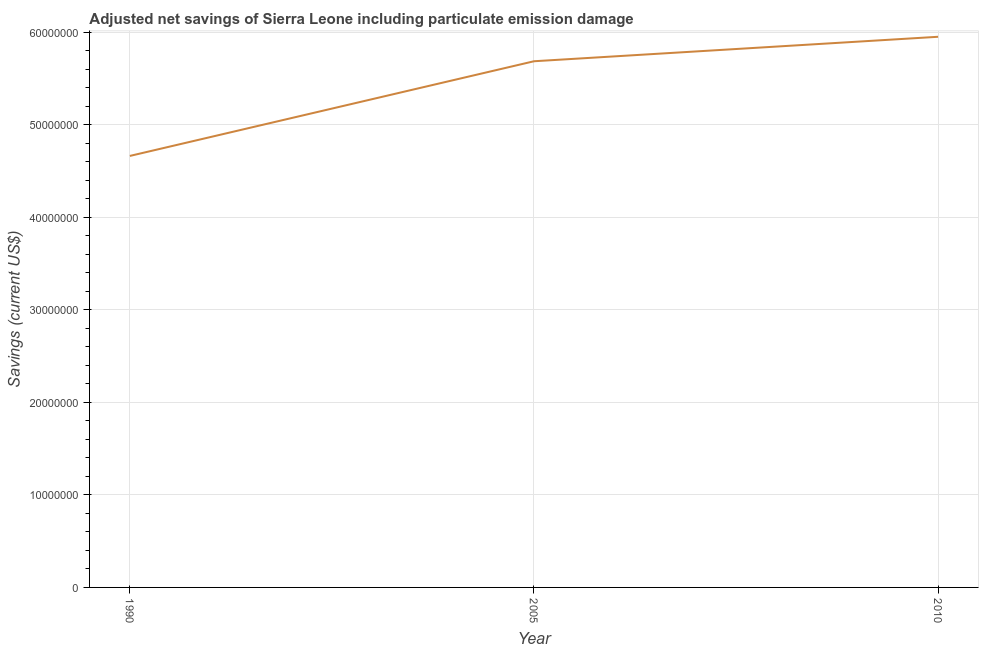What is the adjusted net savings in 1990?
Offer a very short reply. 4.66e+07. Across all years, what is the maximum adjusted net savings?
Make the answer very short. 5.95e+07. Across all years, what is the minimum adjusted net savings?
Your response must be concise. 4.66e+07. In which year was the adjusted net savings minimum?
Give a very brief answer. 1990. What is the sum of the adjusted net savings?
Ensure brevity in your answer.  1.63e+08. What is the difference between the adjusted net savings in 1990 and 2010?
Provide a succinct answer. -1.29e+07. What is the average adjusted net savings per year?
Provide a short and direct response. 5.43e+07. What is the median adjusted net savings?
Provide a short and direct response. 5.69e+07. In how many years, is the adjusted net savings greater than 38000000 US$?
Ensure brevity in your answer.  3. What is the ratio of the adjusted net savings in 2005 to that in 2010?
Your answer should be very brief. 0.96. Is the difference between the adjusted net savings in 2005 and 2010 greater than the difference between any two years?
Your answer should be compact. No. What is the difference between the highest and the second highest adjusted net savings?
Provide a succinct answer. 2.64e+06. What is the difference between the highest and the lowest adjusted net savings?
Give a very brief answer. 1.29e+07. In how many years, is the adjusted net savings greater than the average adjusted net savings taken over all years?
Your response must be concise. 2. Does the adjusted net savings monotonically increase over the years?
Offer a very short reply. Yes. How many years are there in the graph?
Offer a terse response. 3. What is the difference between two consecutive major ticks on the Y-axis?
Provide a succinct answer. 1.00e+07. Are the values on the major ticks of Y-axis written in scientific E-notation?
Give a very brief answer. No. What is the title of the graph?
Provide a short and direct response. Adjusted net savings of Sierra Leone including particulate emission damage. What is the label or title of the Y-axis?
Make the answer very short. Savings (current US$). What is the Savings (current US$) of 1990?
Provide a short and direct response. 4.66e+07. What is the Savings (current US$) in 2005?
Offer a terse response. 5.69e+07. What is the Savings (current US$) in 2010?
Your response must be concise. 5.95e+07. What is the difference between the Savings (current US$) in 1990 and 2005?
Give a very brief answer. -1.02e+07. What is the difference between the Savings (current US$) in 1990 and 2010?
Make the answer very short. -1.29e+07. What is the difference between the Savings (current US$) in 2005 and 2010?
Provide a succinct answer. -2.64e+06. What is the ratio of the Savings (current US$) in 1990 to that in 2005?
Provide a succinct answer. 0.82. What is the ratio of the Savings (current US$) in 1990 to that in 2010?
Provide a short and direct response. 0.78. What is the ratio of the Savings (current US$) in 2005 to that in 2010?
Provide a short and direct response. 0.96. 